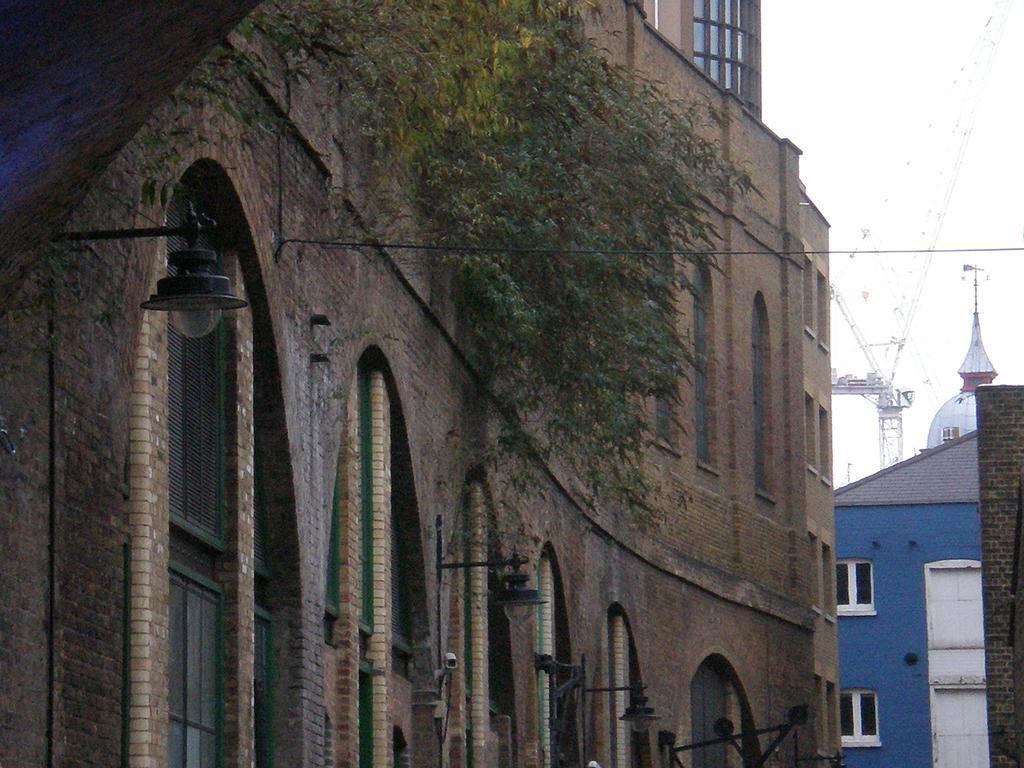Please provide a concise description of this image. In this image I can see few buildings, wires and a tree. 